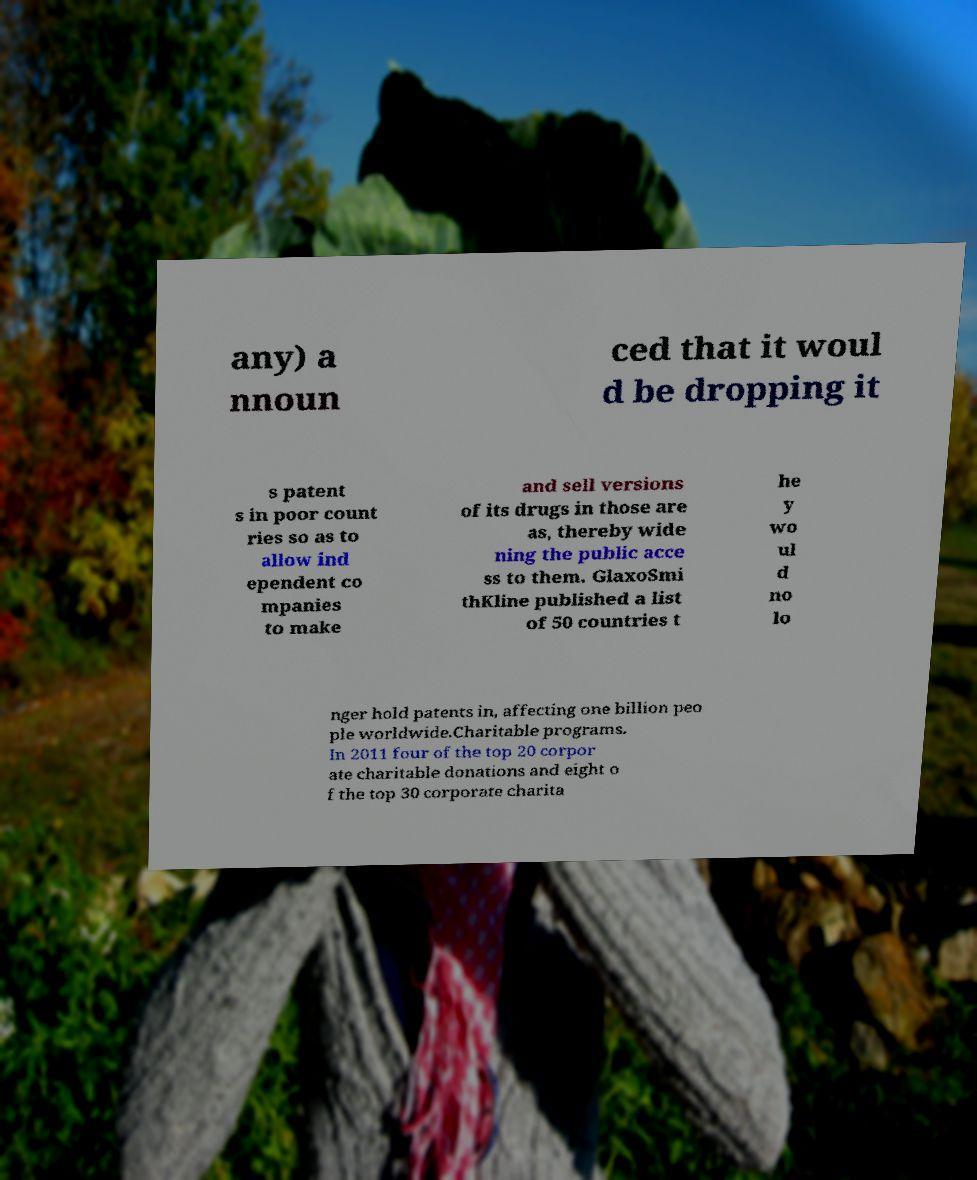What messages or text are displayed in this image? I need them in a readable, typed format. any) a nnoun ced that it woul d be dropping it s patent s in poor count ries so as to allow ind ependent co mpanies to make and sell versions of its drugs in those are as, thereby wide ning the public acce ss to them. GlaxoSmi thKline published a list of 50 countries t he y wo ul d no lo nger hold patents in, affecting one billion peo ple worldwide.Charitable programs. In 2011 four of the top 20 corpor ate charitable donations and eight o f the top 30 corporate charita 